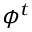Convert formula to latex. <formula><loc_0><loc_0><loc_500><loc_500>\phi ^ { t }</formula> 